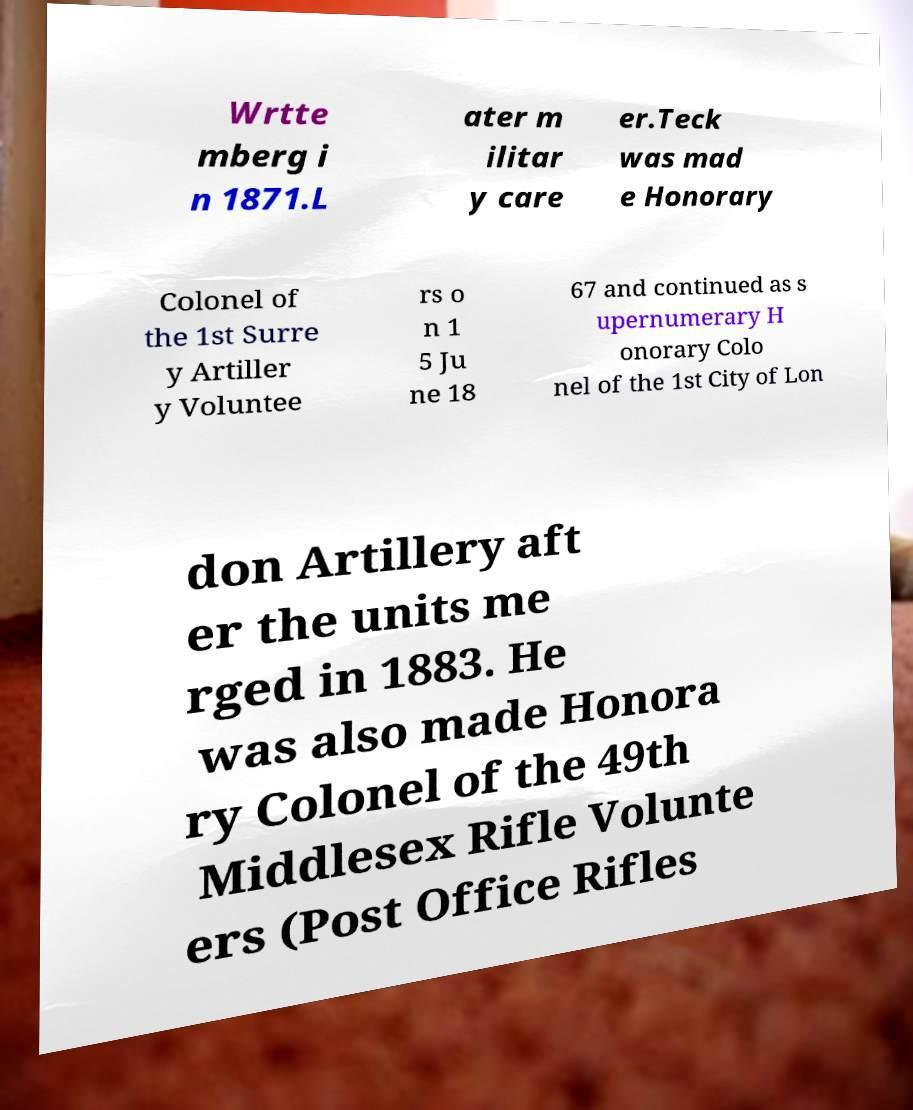Can you read and provide the text displayed in the image?This photo seems to have some interesting text. Can you extract and type it out for me? Wrtte mberg i n 1871.L ater m ilitar y care er.Teck was mad e Honorary Colonel of the 1st Surre y Artiller y Voluntee rs o n 1 5 Ju ne 18 67 and continued as s upernumerary H onorary Colo nel of the 1st City of Lon don Artillery aft er the units me rged in 1883. He was also made Honora ry Colonel of the 49th Middlesex Rifle Volunte ers (Post Office Rifles 